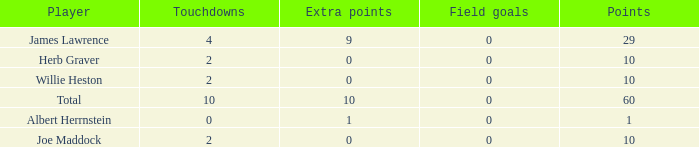What is the highest number of extra points for players with less than 2 touchdowns and less than 1 point? None. 